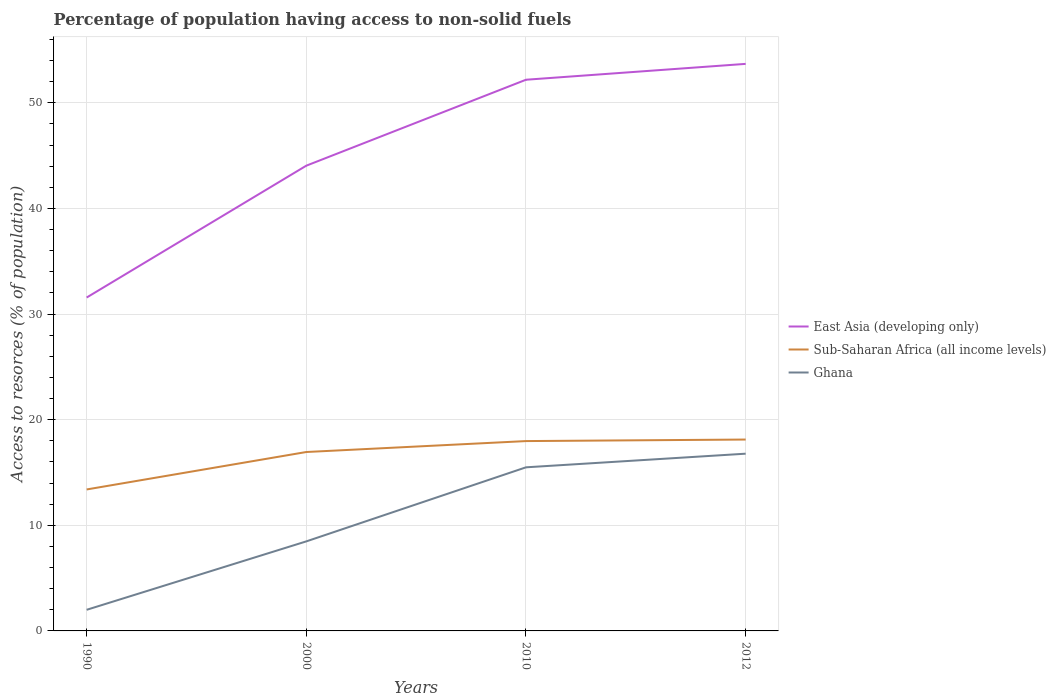How many different coloured lines are there?
Provide a succinct answer. 3. Across all years, what is the maximum percentage of population having access to non-solid fuels in Sub-Saharan Africa (all income levels)?
Give a very brief answer. 13.4. What is the total percentage of population having access to non-solid fuels in Ghana in the graph?
Make the answer very short. -7.01. What is the difference between the highest and the second highest percentage of population having access to non-solid fuels in East Asia (developing only)?
Provide a short and direct response. 22.12. What is the difference between the highest and the lowest percentage of population having access to non-solid fuels in East Asia (developing only)?
Make the answer very short. 2. How many lines are there?
Provide a succinct answer. 3. How many years are there in the graph?
Offer a very short reply. 4. Are the values on the major ticks of Y-axis written in scientific E-notation?
Offer a very short reply. No. Does the graph contain any zero values?
Offer a terse response. No. Does the graph contain grids?
Offer a terse response. Yes. What is the title of the graph?
Keep it short and to the point. Percentage of population having access to non-solid fuels. Does "Israel" appear as one of the legend labels in the graph?
Make the answer very short. No. What is the label or title of the Y-axis?
Your answer should be very brief. Access to resorces (% of population). What is the Access to resorces (% of population) of East Asia (developing only) in 1990?
Your response must be concise. 31.57. What is the Access to resorces (% of population) in Sub-Saharan Africa (all income levels) in 1990?
Your answer should be compact. 13.4. What is the Access to resorces (% of population) in Ghana in 1990?
Make the answer very short. 2. What is the Access to resorces (% of population) in East Asia (developing only) in 2000?
Offer a very short reply. 44.05. What is the Access to resorces (% of population) in Sub-Saharan Africa (all income levels) in 2000?
Keep it short and to the point. 16.94. What is the Access to resorces (% of population) in Ghana in 2000?
Your answer should be very brief. 8.48. What is the Access to resorces (% of population) in East Asia (developing only) in 2010?
Offer a terse response. 52.19. What is the Access to resorces (% of population) in Sub-Saharan Africa (all income levels) in 2010?
Provide a short and direct response. 17.98. What is the Access to resorces (% of population) in Ghana in 2010?
Ensure brevity in your answer.  15.49. What is the Access to resorces (% of population) in East Asia (developing only) in 2012?
Your answer should be compact. 53.69. What is the Access to resorces (% of population) of Sub-Saharan Africa (all income levels) in 2012?
Your answer should be compact. 18.12. What is the Access to resorces (% of population) of Ghana in 2012?
Ensure brevity in your answer.  16.78. Across all years, what is the maximum Access to resorces (% of population) of East Asia (developing only)?
Offer a very short reply. 53.69. Across all years, what is the maximum Access to resorces (% of population) of Sub-Saharan Africa (all income levels)?
Provide a succinct answer. 18.12. Across all years, what is the maximum Access to resorces (% of population) of Ghana?
Provide a short and direct response. 16.78. Across all years, what is the minimum Access to resorces (% of population) of East Asia (developing only)?
Make the answer very short. 31.57. Across all years, what is the minimum Access to resorces (% of population) in Sub-Saharan Africa (all income levels)?
Offer a terse response. 13.4. Across all years, what is the minimum Access to resorces (% of population) in Ghana?
Your answer should be compact. 2. What is the total Access to resorces (% of population) in East Asia (developing only) in the graph?
Provide a succinct answer. 181.5. What is the total Access to resorces (% of population) in Sub-Saharan Africa (all income levels) in the graph?
Make the answer very short. 66.43. What is the total Access to resorces (% of population) of Ghana in the graph?
Keep it short and to the point. 42.75. What is the difference between the Access to resorces (% of population) of East Asia (developing only) in 1990 and that in 2000?
Your response must be concise. -12.49. What is the difference between the Access to resorces (% of population) in Sub-Saharan Africa (all income levels) in 1990 and that in 2000?
Provide a short and direct response. -3.55. What is the difference between the Access to resorces (% of population) of Ghana in 1990 and that in 2000?
Your response must be concise. -6.48. What is the difference between the Access to resorces (% of population) of East Asia (developing only) in 1990 and that in 2010?
Ensure brevity in your answer.  -20.62. What is the difference between the Access to resorces (% of population) in Sub-Saharan Africa (all income levels) in 1990 and that in 2010?
Your answer should be very brief. -4.58. What is the difference between the Access to resorces (% of population) in Ghana in 1990 and that in 2010?
Offer a terse response. -13.49. What is the difference between the Access to resorces (% of population) in East Asia (developing only) in 1990 and that in 2012?
Offer a terse response. -22.12. What is the difference between the Access to resorces (% of population) in Sub-Saharan Africa (all income levels) in 1990 and that in 2012?
Your answer should be very brief. -4.72. What is the difference between the Access to resorces (% of population) of Ghana in 1990 and that in 2012?
Make the answer very short. -14.78. What is the difference between the Access to resorces (% of population) of East Asia (developing only) in 2000 and that in 2010?
Keep it short and to the point. -8.14. What is the difference between the Access to resorces (% of population) in Sub-Saharan Africa (all income levels) in 2000 and that in 2010?
Your response must be concise. -1.03. What is the difference between the Access to resorces (% of population) of Ghana in 2000 and that in 2010?
Your answer should be compact. -7.01. What is the difference between the Access to resorces (% of population) of East Asia (developing only) in 2000 and that in 2012?
Provide a short and direct response. -9.64. What is the difference between the Access to resorces (% of population) in Sub-Saharan Africa (all income levels) in 2000 and that in 2012?
Ensure brevity in your answer.  -1.18. What is the difference between the Access to resorces (% of population) of Ghana in 2000 and that in 2012?
Provide a succinct answer. -8.3. What is the difference between the Access to resorces (% of population) of East Asia (developing only) in 2010 and that in 2012?
Offer a very short reply. -1.5. What is the difference between the Access to resorces (% of population) in Sub-Saharan Africa (all income levels) in 2010 and that in 2012?
Offer a very short reply. -0.14. What is the difference between the Access to resorces (% of population) in Ghana in 2010 and that in 2012?
Your answer should be compact. -1.29. What is the difference between the Access to resorces (% of population) of East Asia (developing only) in 1990 and the Access to resorces (% of population) of Sub-Saharan Africa (all income levels) in 2000?
Offer a terse response. 14.63. What is the difference between the Access to resorces (% of population) of East Asia (developing only) in 1990 and the Access to resorces (% of population) of Ghana in 2000?
Give a very brief answer. 23.09. What is the difference between the Access to resorces (% of population) in Sub-Saharan Africa (all income levels) in 1990 and the Access to resorces (% of population) in Ghana in 2000?
Provide a succinct answer. 4.92. What is the difference between the Access to resorces (% of population) in East Asia (developing only) in 1990 and the Access to resorces (% of population) in Sub-Saharan Africa (all income levels) in 2010?
Give a very brief answer. 13.59. What is the difference between the Access to resorces (% of population) in East Asia (developing only) in 1990 and the Access to resorces (% of population) in Ghana in 2010?
Make the answer very short. 16.08. What is the difference between the Access to resorces (% of population) in Sub-Saharan Africa (all income levels) in 1990 and the Access to resorces (% of population) in Ghana in 2010?
Provide a short and direct response. -2.1. What is the difference between the Access to resorces (% of population) in East Asia (developing only) in 1990 and the Access to resorces (% of population) in Sub-Saharan Africa (all income levels) in 2012?
Ensure brevity in your answer.  13.45. What is the difference between the Access to resorces (% of population) in East Asia (developing only) in 1990 and the Access to resorces (% of population) in Ghana in 2012?
Provide a short and direct response. 14.79. What is the difference between the Access to resorces (% of population) of Sub-Saharan Africa (all income levels) in 1990 and the Access to resorces (% of population) of Ghana in 2012?
Your response must be concise. -3.39. What is the difference between the Access to resorces (% of population) of East Asia (developing only) in 2000 and the Access to resorces (% of population) of Sub-Saharan Africa (all income levels) in 2010?
Provide a short and direct response. 26.08. What is the difference between the Access to resorces (% of population) of East Asia (developing only) in 2000 and the Access to resorces (% of population) of Ghana in 2010?
Provide a short and direct response. 28.56. What is the difference between the Access to resorces (% of population) in Sub-Saharan Africa (all income levels) in 2000 and the Access to resorces (% of population) in Ghana in 2010?
Offer a very short reply. 1.45. What is the difference between the Access to resorces (% of population) in East Asia (developing only) in 2000 and the Access to resorces (% of population) in Sub-Saharan Africa (all income levels) in 2012?
Ensure brevity in your answer.  25.93. What is the difference between the Access to resorces (% of population) in East Asia (developing only) in 2000 and the Access to resorces (% of population) in Ghana in 2012?
Give a very brief answer. 27.27. What is the difference between the Access to resorces (% of population) of Sub-Saharan Africa (all income levels) in 2000 and the Access to resorces (% of population) of Ghana in 2012?
Provide a succinct answer. 0.16. What is the difference between the Access to resorces (% of population) in East Asia (developing only) in 2010 and the Access to resorces (% of population) in Sub-Saharan Africa (all income levels) in 2012?
Provide a short and direct response. 34.07. What is the difference between the Access to resorces (% of population) in East Asia (developing only) in 2010 and the Access to resorces (% of population) in Ghana in 2012?
Ensure brevity in your answer.  35.41. What is the difference between the Access to resorces (% of population) in Sub-Saharan Africa (all income levels) in 2010 and the Access to resorces (% of population) in Ghana in 2012?
Ensure brevity in your answer.  1.19. What is the average Access to resorces (% of population) in East Asia (developing only) per year?
Offer a very short reply. 45.38. What is the average Access to resorces (% of population) of Sub-Saharan Africa (all income levels) per year?
Your response must be concise. 16.61. What is the average Access to resorces (% of population) of Ghana per year?
Keep it short and to the point. 10.69. In the year 1990, what is the difference between the Access to resorces (% of population) of East Asia (developing only) and Access to resorces (% of population) of Sub-Saharan Africa (all income levels)?
Make the answer very short. 18.17. In the year 1990, what is the difference between the Access to resorces (% of population) of East Asia (developing only) and Access to resorces (% of population) of Ghana?
Offer a very short reply. 29.57. In the year 1990, what is the difference between the Access to resorces (% of population) in Sub-Saharan Africa (all income levels) and Access to resorces (% of population) in Ghana?
Give a very brief answer. 11.4. In the year 2000, what is the difference between the Access to resorces (% of population) of East Asia (developing only) and Access to resorces (% of population) of Sub-Saharan Africa (all income levels)?
Offer a very short reply. 27.11. In the year 2000, what is the difference between the Access to resorces (% of population) in East Asia (developing only) and Access to resorces (% of population) in Ghana?
Offer a very short reply. 35.58. In the year 2000, what is the difference between the Access to resorces (% of population) in Sub-Saharan Africa (all income levels) and Access to resorces (% of population) in Ghana?
Offer a terse response. 8.46. In the year 2010, what is the difference between the Access to resorces (% of population) of East Asia (developing only) and Access to resorces (% of population) of Sub-Saharan Africa (all income levels)?
Give a very brief answer. 34.21. In the year 2010, what is the difference between the Access to resorces (% of population) of East Asia (developing only) and Access to resorces (% of population) of Ghana?
Your answer should be very brief. 36.7. In the year 2010, what is the difference between the Access to resorces (% of population) in Sub-Saharan Africa (all income levels) and Access to resorces (% of population) in Ghana?
Offer a very short reply. 2.48. In the year 2012, what is the difference between the Access to resorces (% of population) in East Asia (developing only) and Access to resorces (% of population) in Sub-Saharan Africa (all income levels)?
Your answer should be compact. 35.57. In the year 2012, what is the difference between the Access to resorces (% of population) of East Asia (developing only) and Access to resorces (% of population) of Ghana?
Offer a very short reply. 36.91. In the year 2012, what is the difference between the Access to resorces (% of population) in Sub-Saharan Africa (all income levels) and Access to resorces (% of population) in Ghana?
Your response must be concise. 1.34. What is the ratio of the Access to resorces (% of population) of East Asia (developing only) in 1990 to that in 2000?
Your answer should be very brief. 0.72. What is the ratio of the Access to resorces (% of population) of Sub-Saharan Africa (all income levels) in 1990 to that in 2000?
Make the answer very short. 0.79. What is the ratio of the Access to resorces (% of population) of Ghana in 1990 to that in 2000?
Your response must be concise. 0.24. What is the ratio of the Access to resorces (% of population) in East Asia (developing only) in 1990 to that in 2010?
Give a very brief answer. 0.6. What is the ratio of the Access to resorces (% of population) in Sub-Saharan Africa (all income levels) in 1990 to that in 2010?
Offer a terse response. 0.75. What is the ratio of the Access to resorces (% of population) of Ghana in 1990 to that in 2010?
Your answer should be compact. 0.13. What is the ratio of the Access to resorces (% of population) of East Asia (developing only) in 1990 to that in 2012?
Provide a succinct answer. 0.59. What is the ratio of the Access to resorces (% of population) of Sub-Saharan Africa (all income levels) in 1990 to that in 2012?
Keep it short and to the point. 0.74. What is the ratio of the Access to resorces (% of population) in Ghana in 1990 to that in 2012?
Your answer should be compact. 0.12. What is the ratio of the Access to resorces (% of population) in East Asia (developing only) in 2000 to that in 2010?
Make the answer very short. 0.84. What is the ratio of the Access to resorces (% of population) in Sub-Saharan Africa (all income levels) in 2000 to that in 2010?
Keep it short and to the point. 0.94. What is the ratio of the Access to resorces (% of population) in Ghana in 2000 to that in 2010?
Give a very brief answer. 0.55. What is the ratio of the Access to resorces (% of population) in East Asia (developing only) in 2000 to that in 2012?
Your response must be concise. 0.82. What is the ratio of the Access to resorces (% of population) of Sub-Saharan Africa (all income levels) in 2000 to that in 2012?
Give a very brief answer. 0.93. What is the ratio of the Access to resorces (% of population) of Ghana in 2000 to that in 2012?
Make the answer very short. 0.51. What is the ratio of the Access to resorces (% of population) of East Asia (developing only) in 2010 to that in 2012?
Your answer should be very brief. 0.97. What is the difference between the highest and the second highest Access to resorces (% of population) of East Asia (developing only)?
Provide a succinct answer. 1.5. What is the difference between the highest and the second highest Access to resorces (% of population) in Sub-Saharan Africa (all income levels)?
Offer a terse response. 0.14. What is the difference between the highest and the second highest Access to resorces (% of population) in Ghana?
Give a very brief answer. 1.29. What is the difference between the highest and the lowest Access to resorces (% of population) of East Asia (developing only)?
Keep it short and to the point. 22.12. What is the difference between the highest and the lowest Access to resorces (% of population) of Sub-Saharan Africa (all income levels)?
Keep it short and to the point. 4.72. What is the difference between the highest and the lowest Access to resorces (% of population) of Ghana?
Make the answer very short. 14.78. 